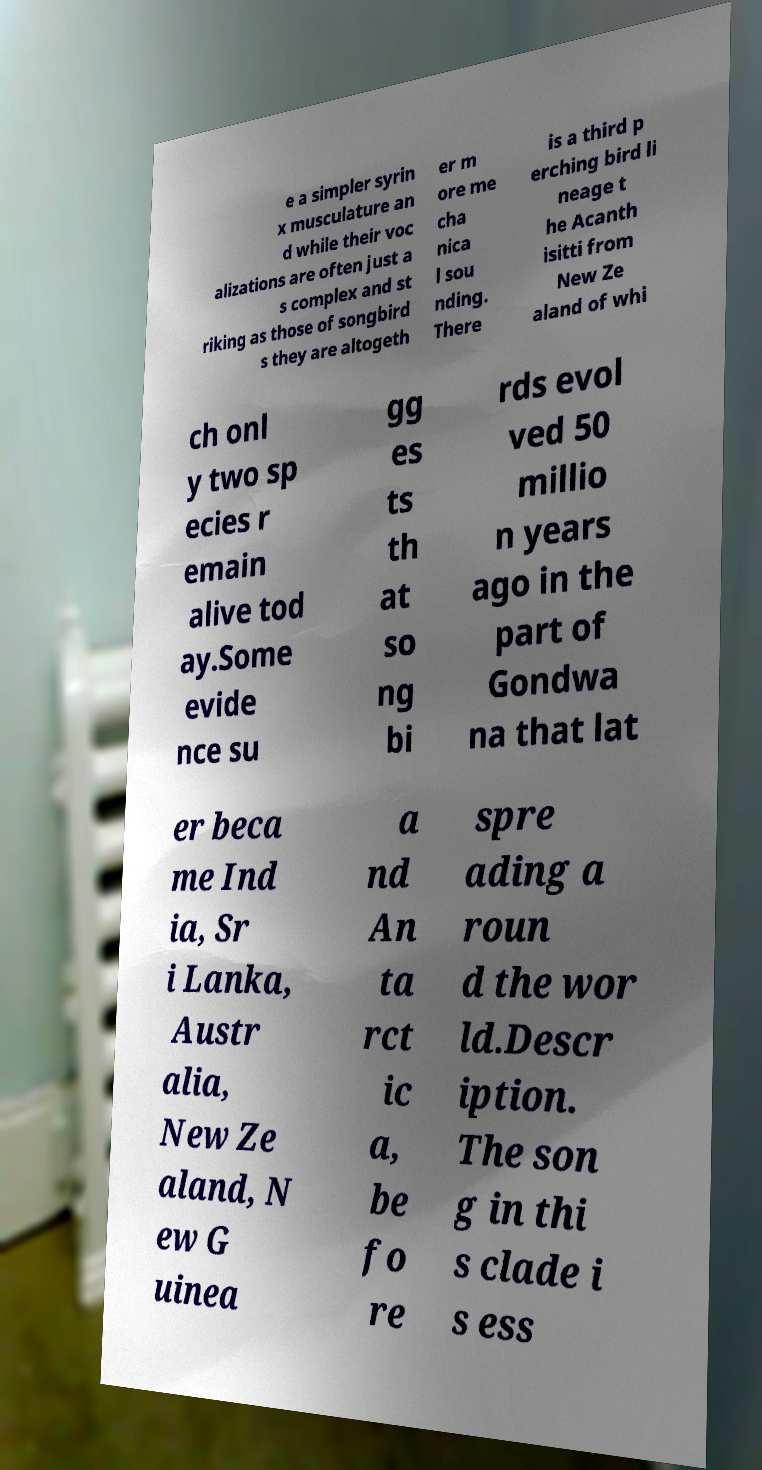Can you accurately transcribe the text from the provided image for me? e a simpler syrin x musculature an d while their voc alizations are often just a s complex and st riking as those of songbird s they are altogeth er m ore me cha nica l sou nding. There is a third p erching bird li neage t he Acanth isitti from New Ze aland of whi ch onl y two sp ecies r emain alive tod ay.Some evide nce su gg es ts th at so ng bi rds evol ved 50 millio n years ago in the part of Gondwa na that lat er beca me Ind ia, Sr i Lanka, Austr alia, New Ze aland, N ew G uinea a nd An ta rct ic a, be fo re spre ading a roun d the wor ld.Descr iption. The son g in thi s clade i s ess 